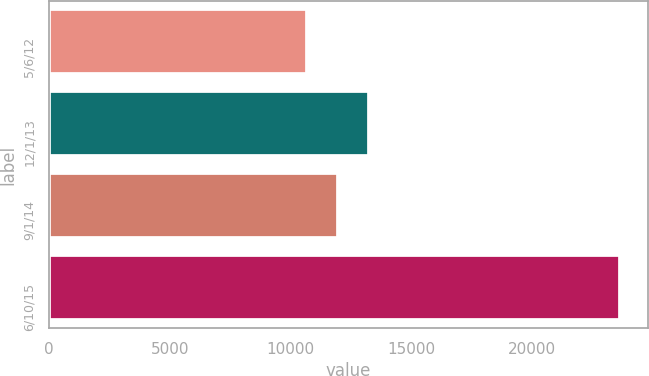Convert chart. <chart><loc_0><loc_0><loc_500><loc_500><bar_chart><fcel>5/6/12<fcel>12/1/13<fcel>9/1/14<fcel>6/10/15<nl><fcel>10664<fcel>13256.2<fcel>11960.1<fcel>23625<nl></chart> 